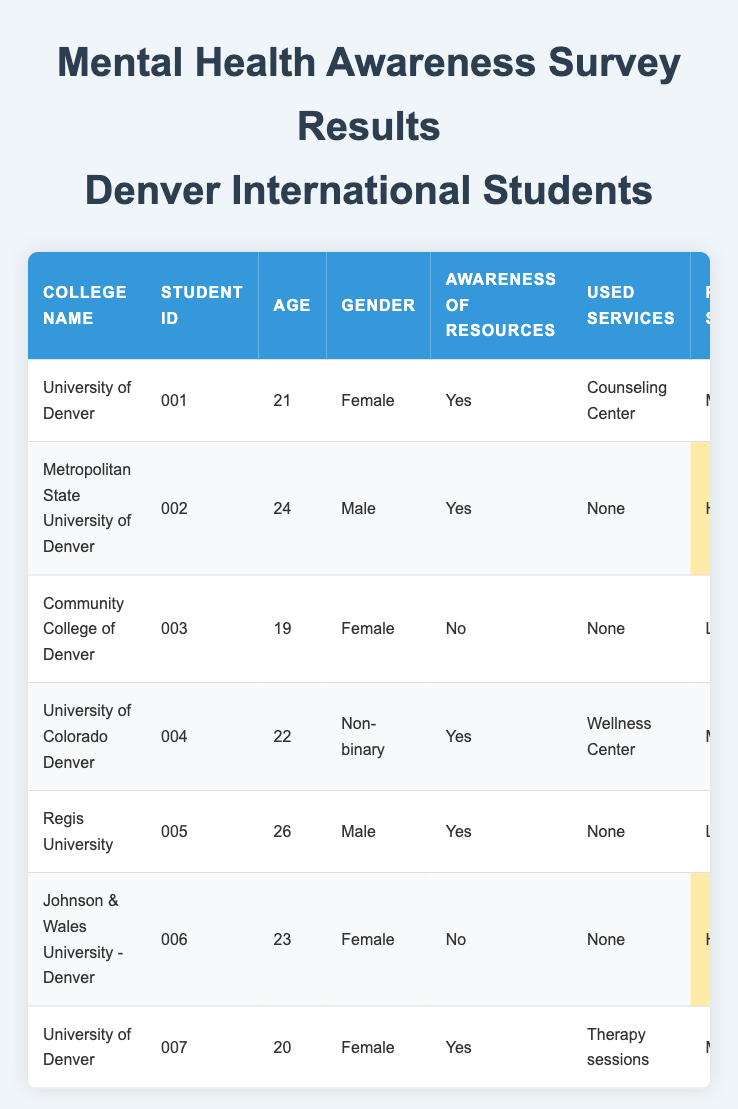What percentage of students are aware of mental health resources? There are 7 students in total. Of those, 4 have indicated awareness of resources. To find the percentage, use the formula: (Number of aware students / Total number of students) * 100 = (4 / 7) * 100 ≈ 57.14%.
Answer: Approximately 57.14% How many students reported using mental health services? Of the 7 students, 3 have indicated that they used mental health services while 4 have reported that they did not use any.
Answer: 3 What is the most common perceived stigma level reported by students? Looking at the table, "Moderate" stigma is reported by 3 students, while "High" and "Low" are reported by 2 and 2 students respectively. Therefore, "Moderate" is the most common level.
Answer: Moderate What is the average age of the students surveyed? The ages are 21, 24, 19, 22, 26, 23, and 20. First, sum these ages: 21 + 24 + 19 + 22 + 26 + 23 + 20 =  159. Then divide by the number of students (7) to find the average: 159 / 7 ≈ 22.71.
Answer: Approximately 22.71 Do more students have a fair or good mental health status? There are 2 students with "Fair," 3 with "Good," and 2 with "Poor" health status. Since "Good" is the highest, more students report a good mental health status.
Answer: Good Which student has the highest perceived stigma? Assessing the perceived stigma levels, the highest level is "High," which is reported by students 002 and 006. Among them, both have the same level, so either could be the answer.
Answer: Student 002 or Student 006 Is there a correlation between awareness of resources and the frequency of stress? The awareness of resources is divided into "Yes" for 4 students (frequency: Weekly, Monthly, and Rarely) and "No" for 3 students (frequency: Daily). Students with "Yes" tend to report less frequent stress compared to students with "No."
Answer: Yes How many students prefer peer support groups? From the table, only 1 student indicated a preference for peer support groups.
Answer: 1 Which college has the student with the poorest mental health status? Student 003 from the Community College of Denver reports the mental health status as "Poor." Looking through the table confirms that this is the only instance of that status.
Answer: Community College of Denver What was the most preferred support type reported by students? Various preferred support types are indicated: "Peer support groups," "Online resources," "Family support," "Counseling sessions," "Workshops," "Support from friends," and "Group therapy." The most common type is not discernible since each is unique.
Answer: No most preferred type 